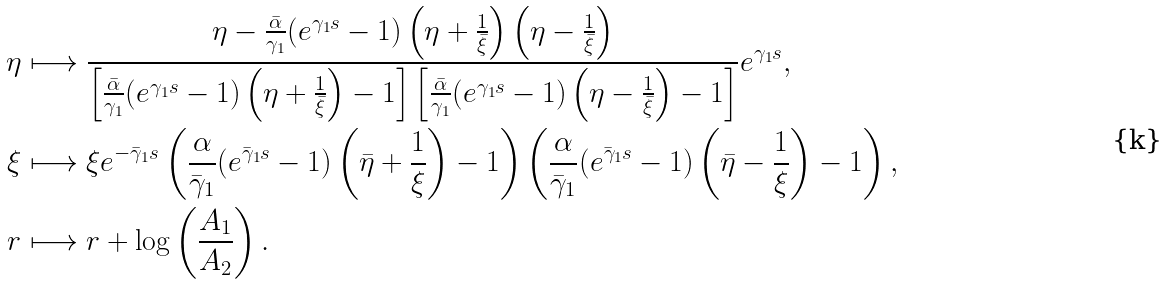Convert formula to latex. <formula><loc_0><loc_0><loc_500><loc_500>\eta & \longmapsto \frac { \eta - \frac { \bar { \alpha } } { \gamma _ { 1 } } ( e ^ { \gamma _ { 1 } s } - 1 ) \left ( \eta + \frac { 1 } { \bar { \xi } } \right ) \left ( \eta - \frac { 1 } { \bar { \xi } } \right ) } { \left [ \frac { \bar { \alpha } } { \gamma _ { 1 } } ( e ^ { \gamma _ { 1 } s } - 1 ) \left ( \eta + \frac { 1 } { \bar { \xi } } \right ) - 1 \right ] \left [ \frac { \bar { \alpha } } { \gamma _ { 1 } } ( e ^ { \gamma _ { 1 } s } - 1 ) \left ( \eta - \frac { 1 } { \bar { \xi } } \right ) - 1 \right ] } e ^ { \gamma _ { 1 } s } , \\ \xi & \longmapsto \xi e ^ { - \bar { \gamma } _ { 1 } s } \left ( \frac { \alpha } { \bar { \gamma } _ { 1 } } ( e ^ { \bar { \gamma } _ { 1 } s } - 1 ) \left ( \bar { \eta } + \frac { 1 } { \xi } \right ) - 1 \right ) \left ( \frac { \alpha } { \bar { \gamma } _ { 1 } } ( e ^ { \bar { \gamma } _ { 1 } s } - 1 ) \left ( \bar { \eta } - \frac { 1 } { \xi } \right ) - 1 \right ) , \\ r & \longmapsto r + \log \left ( \frac { A _ { 1 } } { A _ { 2 } } \right ) .</formula> 